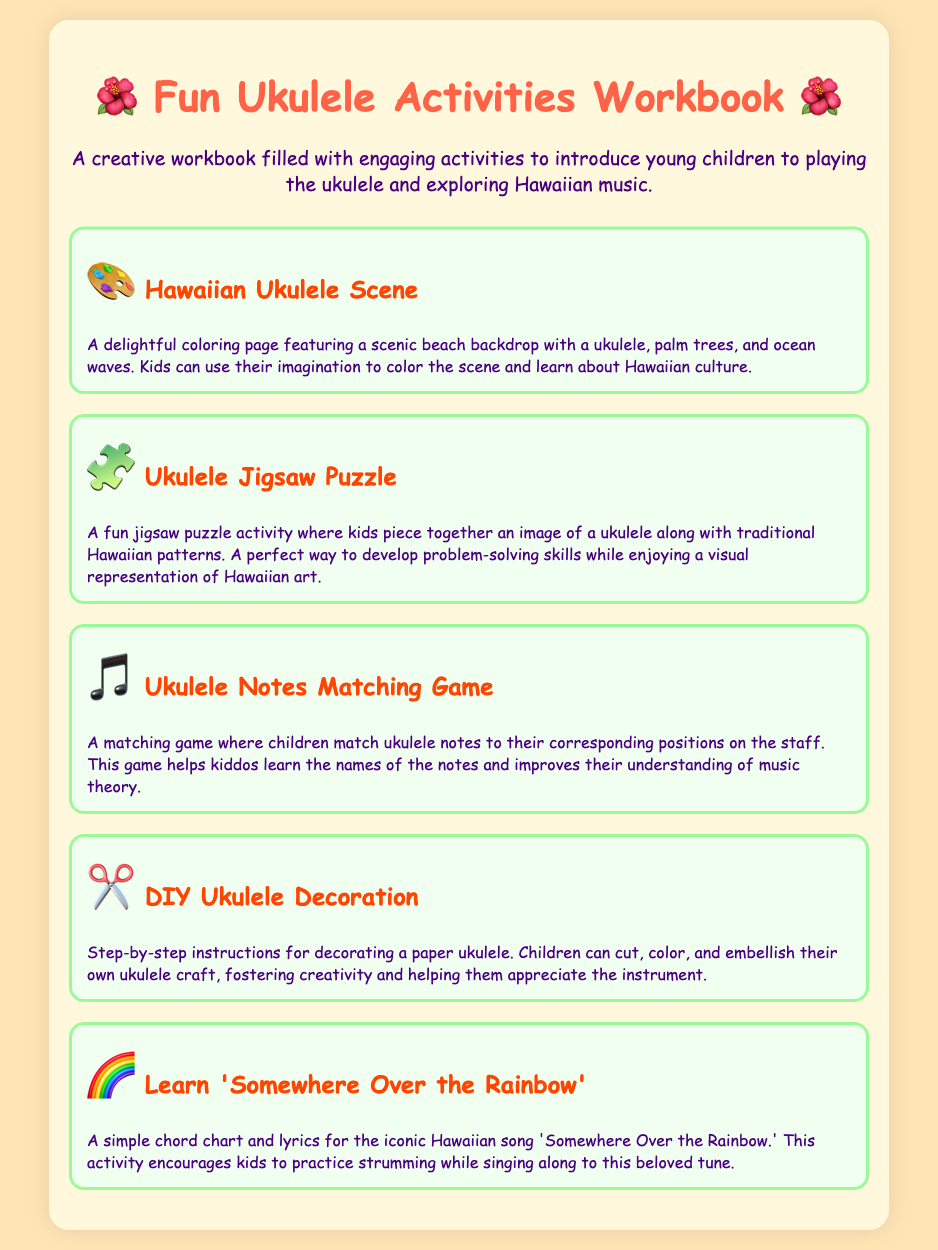What is the title of the workbook? The title is the main heading of the document that describes the content.
Answer: Fun Ukulele Activities Workbook for Young Learners How many activities are listed in the document? The document presents a total number of different activities featured within it.
Answer: Five What is the theme of the activities in the workbook? The theme refers to the central idea or concept around which the activities are organized.
Answer: Ukulele and Hawaiian music What type of game is included to help learn music theory? The type of game specifies the interactive activity related to music theory presented in the document.
Answer: Ukulele Notes Matching Game What activity involves decorating a paper ukulele? This specifies which activity encourages children to enhance their creative skills through decoration.
Answer: DIY Ukulele Decoration Which iconic song can kids learn from this workbook? The question asks for the title of the specific song mentioned in the activities.
Answer: Somewhere Over the Rainbow What character represents the Hawaiian Ukulele Scene activity? The character is used as an icon to visually represent the specific activity in the document.
Answer: 🎨 Which skill does the Ukulele Jigsaw Puzzle activity aim to improve? This describes the main skill development focus of the jigsaw puzzle activity.
Answer: Problem-solving skills What color is the background of the document? The color describes the overall theme and design of the document's appearance.
Answer: #FFE4B5 